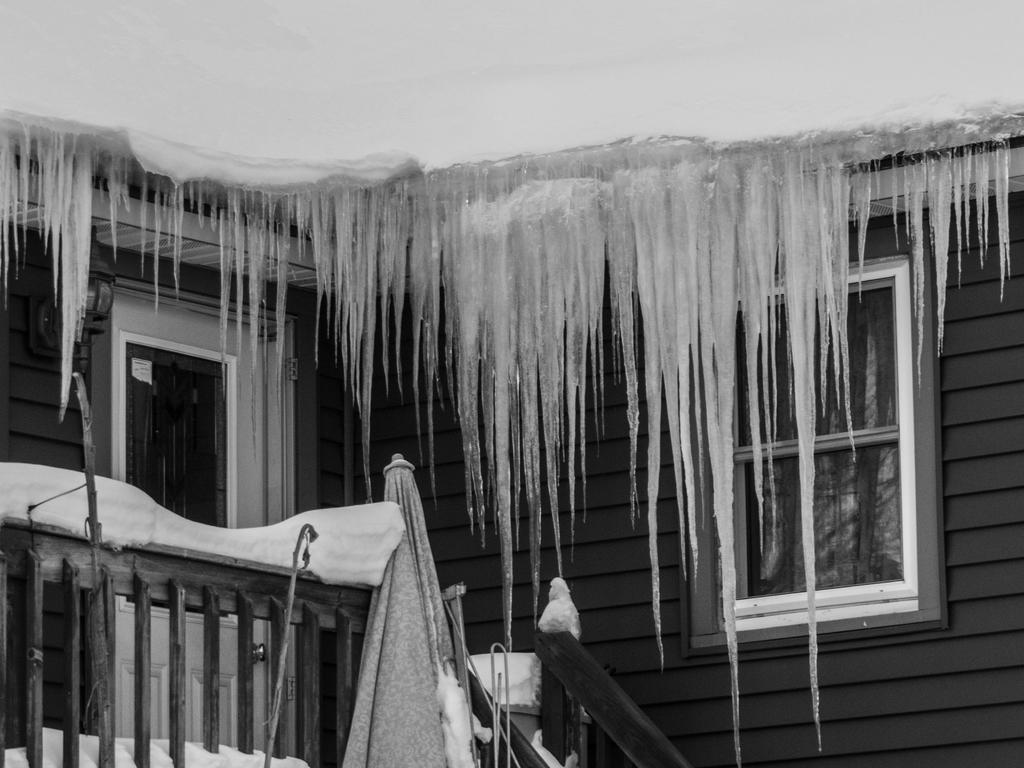Describe this image in one or two sentences. It is a black and white image. In this image we can see the house which is covered with the snow. We can also see the wooden wall, fence, closed umbrella and windows. 